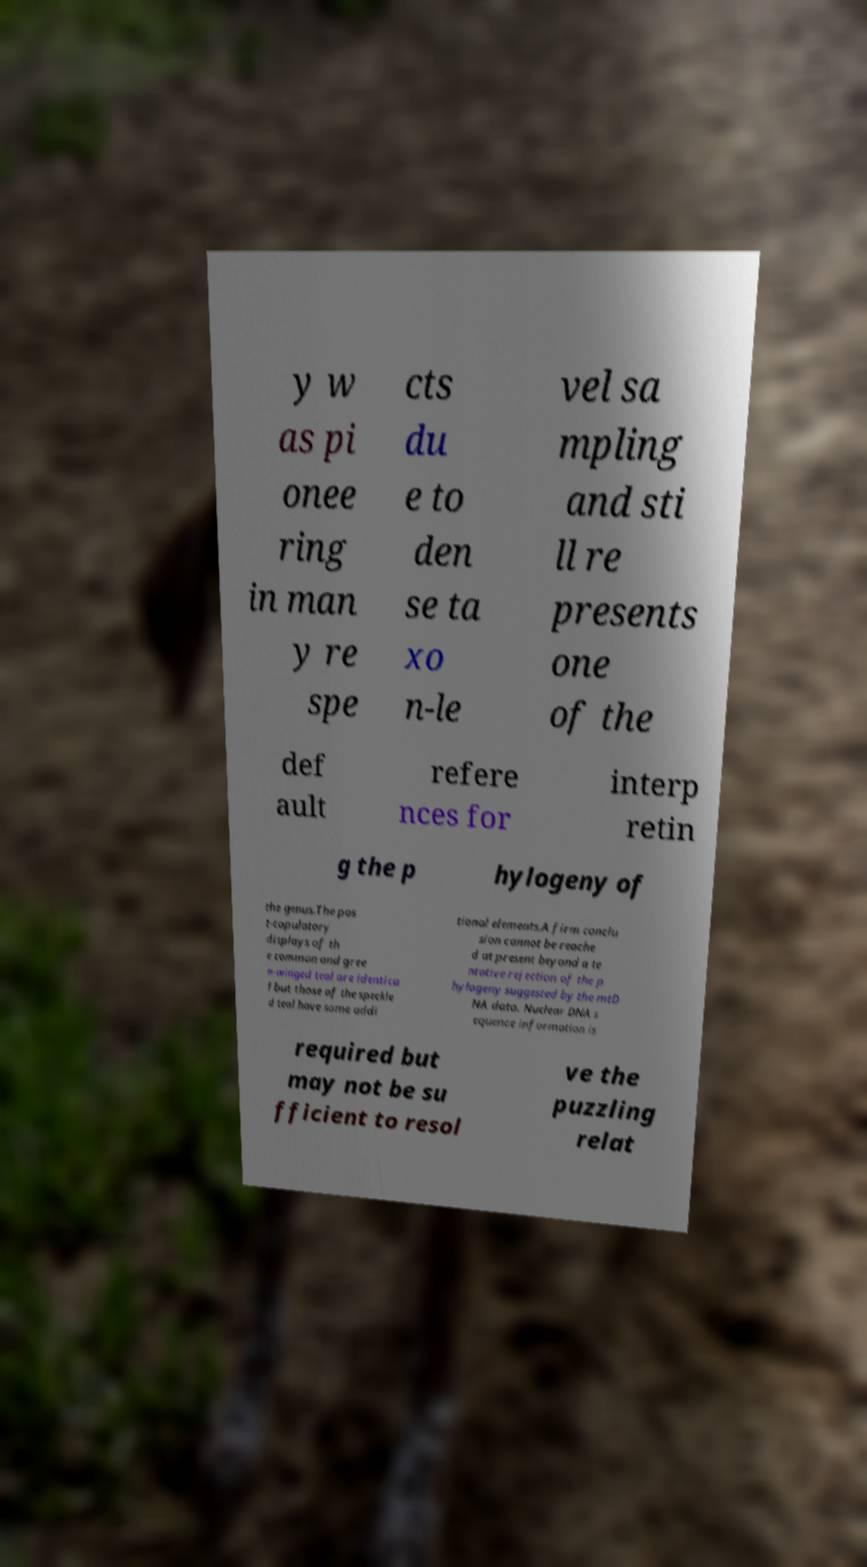For documentation purposes, I need the text within this image transcribed. Could you provide that? y w as pi onee ring in man y re spe cts du e to den se ta xo n-le vel sa mpling and sti ll re presents one of the def ault refere nces for interp retin g the p hylogeny of the genus.The pos t-copulatory displays of th e common and gree n-winged teal are identica l but those of the speckle d teal have some addi tional elements.A firm conclu sion cannot be reache d at present beyond a te ntative rejection of the p hylogeny suggested by the mtD NA data. Nuclear DNA s equence information is required but may not be su fficient to resol ve the puzzling relat 